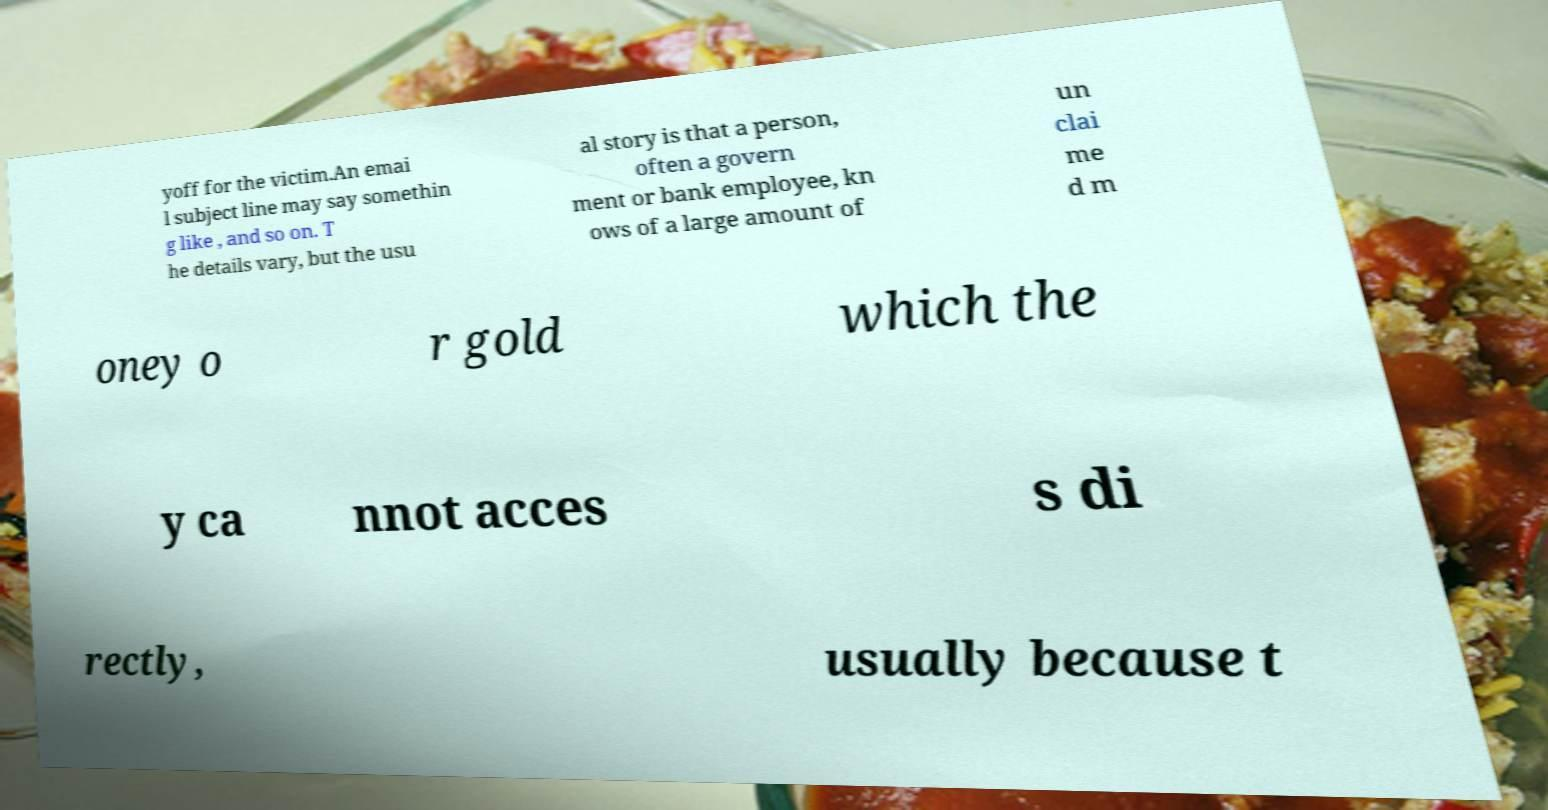Can you accurately transcribe the text from the provided image for me? yoff for the victim.An emai l subject line may say somethin g like , and so on. T he details vary, but the usu al story is that a person, often a govern ment or bank employee, kn ows of a large amount of un clai me d m oney o r gold which the y ca nnot acces s di rectly, usually because t 